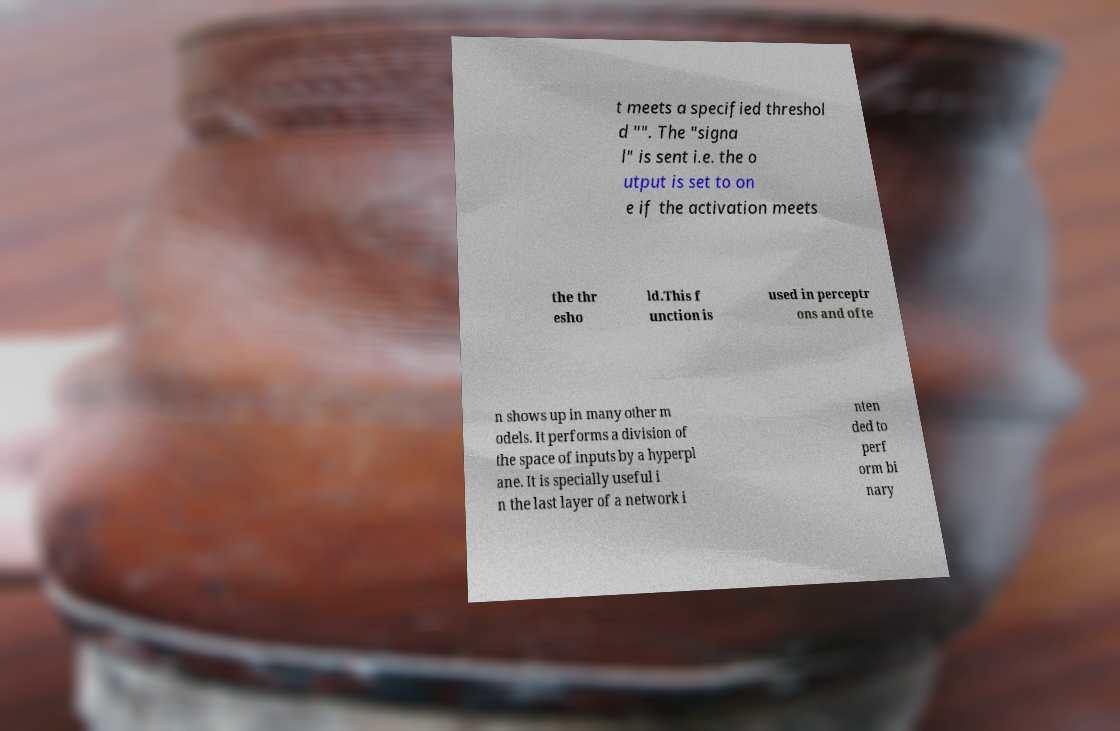There's text embedded in this image that I need extracted. Can you transcribe it verbatim? t meets a specified threshol d "". The "signa l" is sent i.e. the o utput is set to on e if the activation meets the thr esho ld.This f unction is used in perceptr ons and ofte n shows up in many other m odels. It performs a division of the space of inputs by a hyperpl ane. It is specially useful i n the last layer of a network i nten ded to perf orm bi nary 